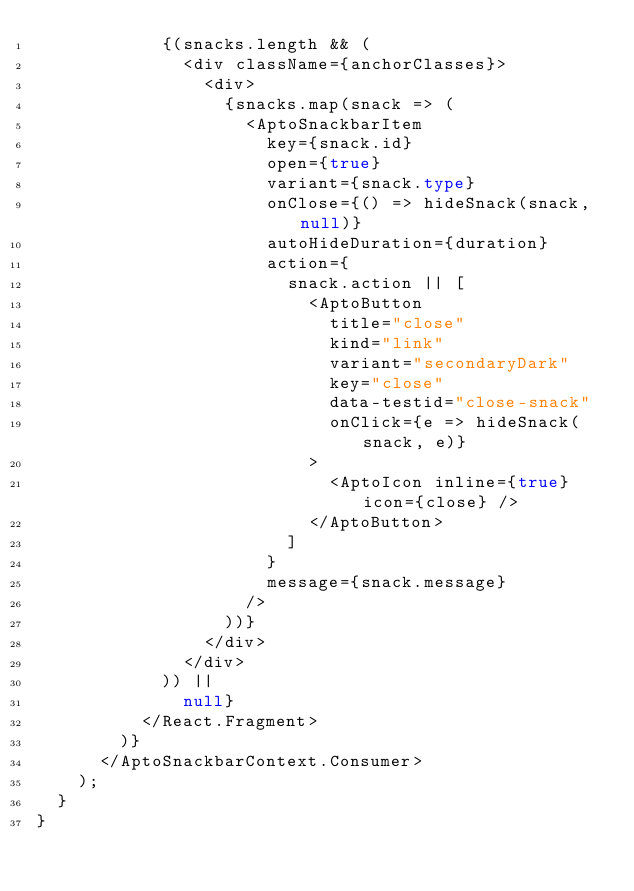Convert code to text. <code><loc_0><loc_0><loc_500><loc_500><_TypeScript_>            {(snacks.length && (
              <div className={anchorClasses}>
                <div>
                  {snacks.map(snack => (
                    <AptoSnackbarItem
                      key={snack.id}
                      open={true}
                      variant={snack.type}
                      onClose={() => hideSnack(snack, null)}
                      autoHideDuration={duration}
                      action={
                        snack.action || [
                          <AptoButton
                            title="close"
                            kind="link"
                            variant="secondaryDark"
                            key="close"
                            data-testid="close-snack"
                            onClick={e => hideSnack(snack, e)}
                          >
                            <AptoIcon inline={true} icon={close} />
                          </AptoButton>
                        ]
                      }
                      message={snack.message}
                    />
                  ))}
                </div>
              </div>
            )) ||
              null}
          </React.Fragment>
        )}
      </AptoSnackbarContext.Consumer>
    );
  }
}
</code> 